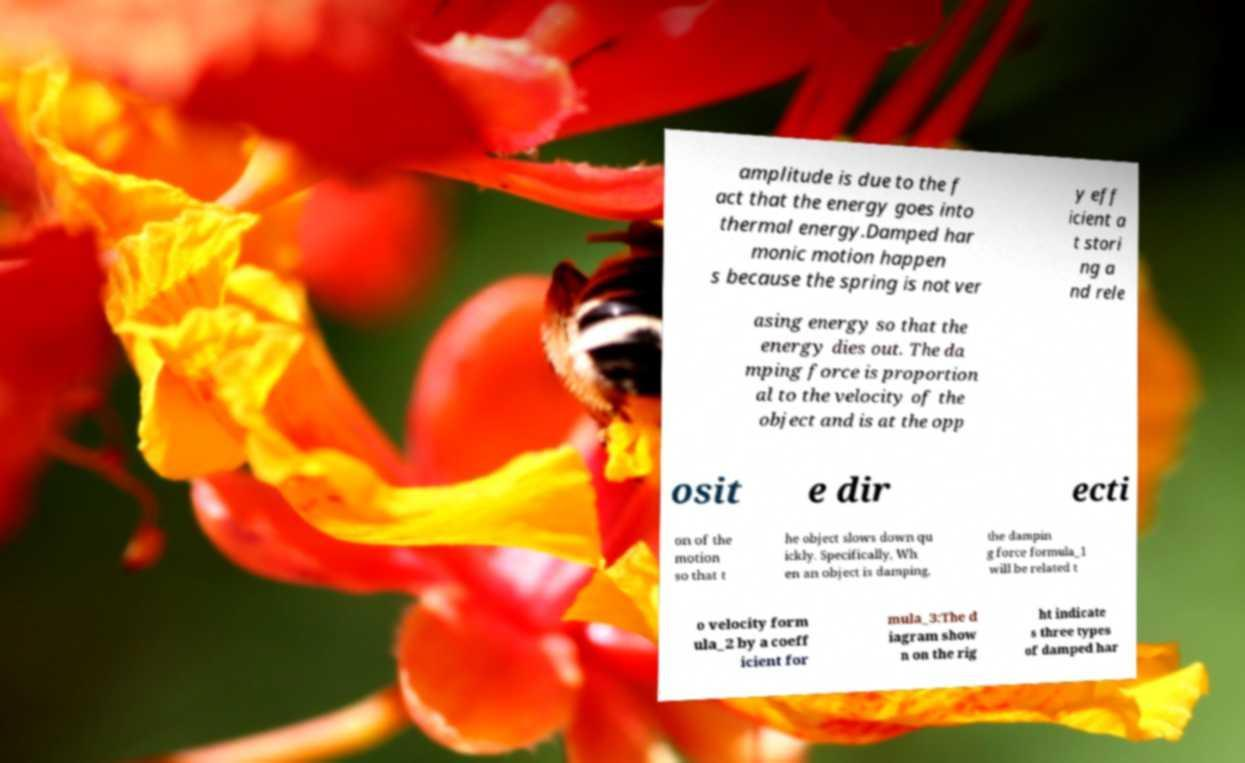Can you read and provide the text displayed in the image?This photo seems to have some interesting text. Can you extract and type it out for me? amplitude is due to the f act that the energy goes into thermal energy.Damped har monic motion happen s because the spring is not ver y eff icient a t stori ng a nd rele asing energy so that the energy dies out. The da mping force is proportion al to the velocity of the object and is at the opp osit e dir ecti on of the motion so that t he object slows down qu ickly. Specifically, Wh en an object is damping, the dampin g force formula_1 will be related t o velocity form ula_2 by a coeff icient for mula_3:The d iagram show n on the rig ht indicate s three types of damped har 